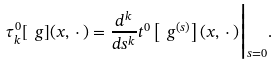<formula> <loc_0><loc_0><loc_500><loc_500>\tau ^ { 0 } _ { k } [ \ g ] ( x , \, \cdot \, ) = \frac { d ^ { k } } { d s ^ { k } } t ^ { 0 } \left [ \ g ^ { ( s ) } \right ] ( x , \, \cdot \, ) \Big | _ { s = 0 } .</formula> 